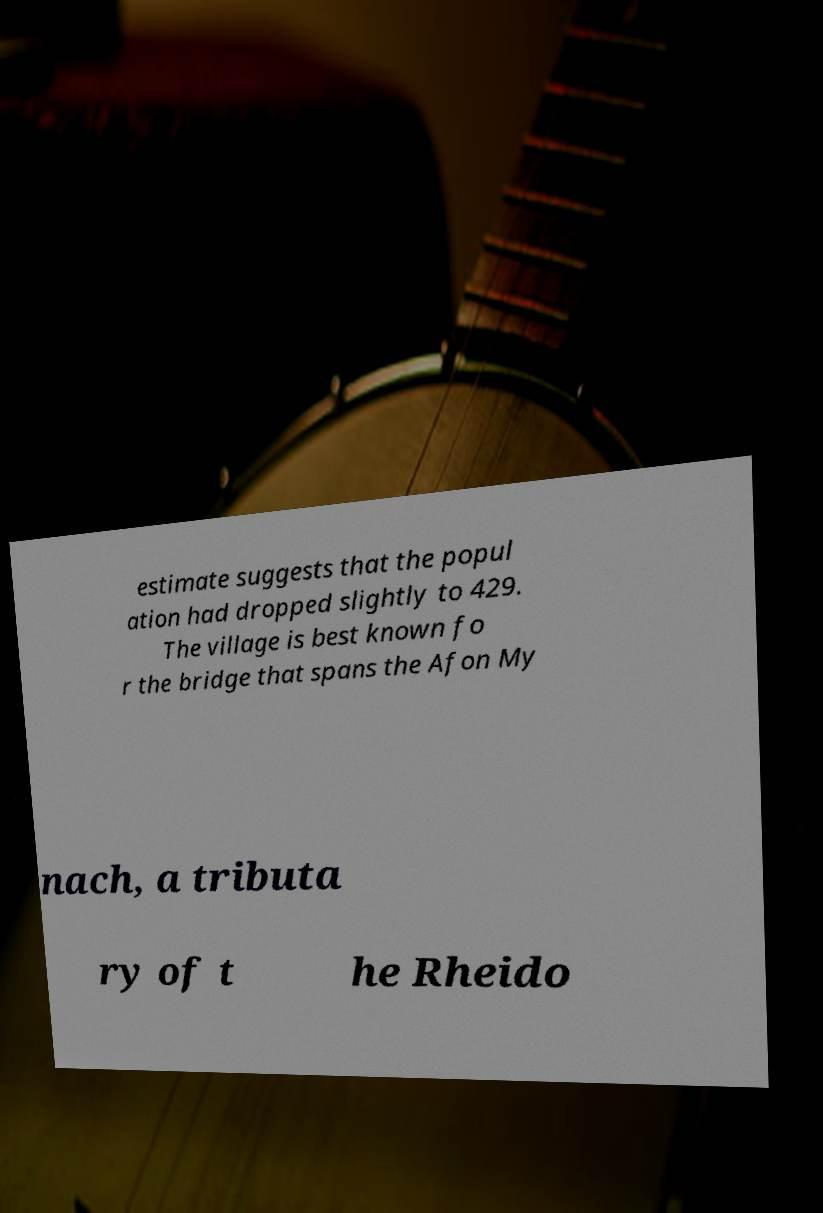There's text embedded in this image that I need extracted. Can you transcribe it verbatim? estimate suggests that the popul ation had dropped slightly to 429. The village is best known fo r the bridge that spans the Afon My nach, a tributa ry of t he Rheido 